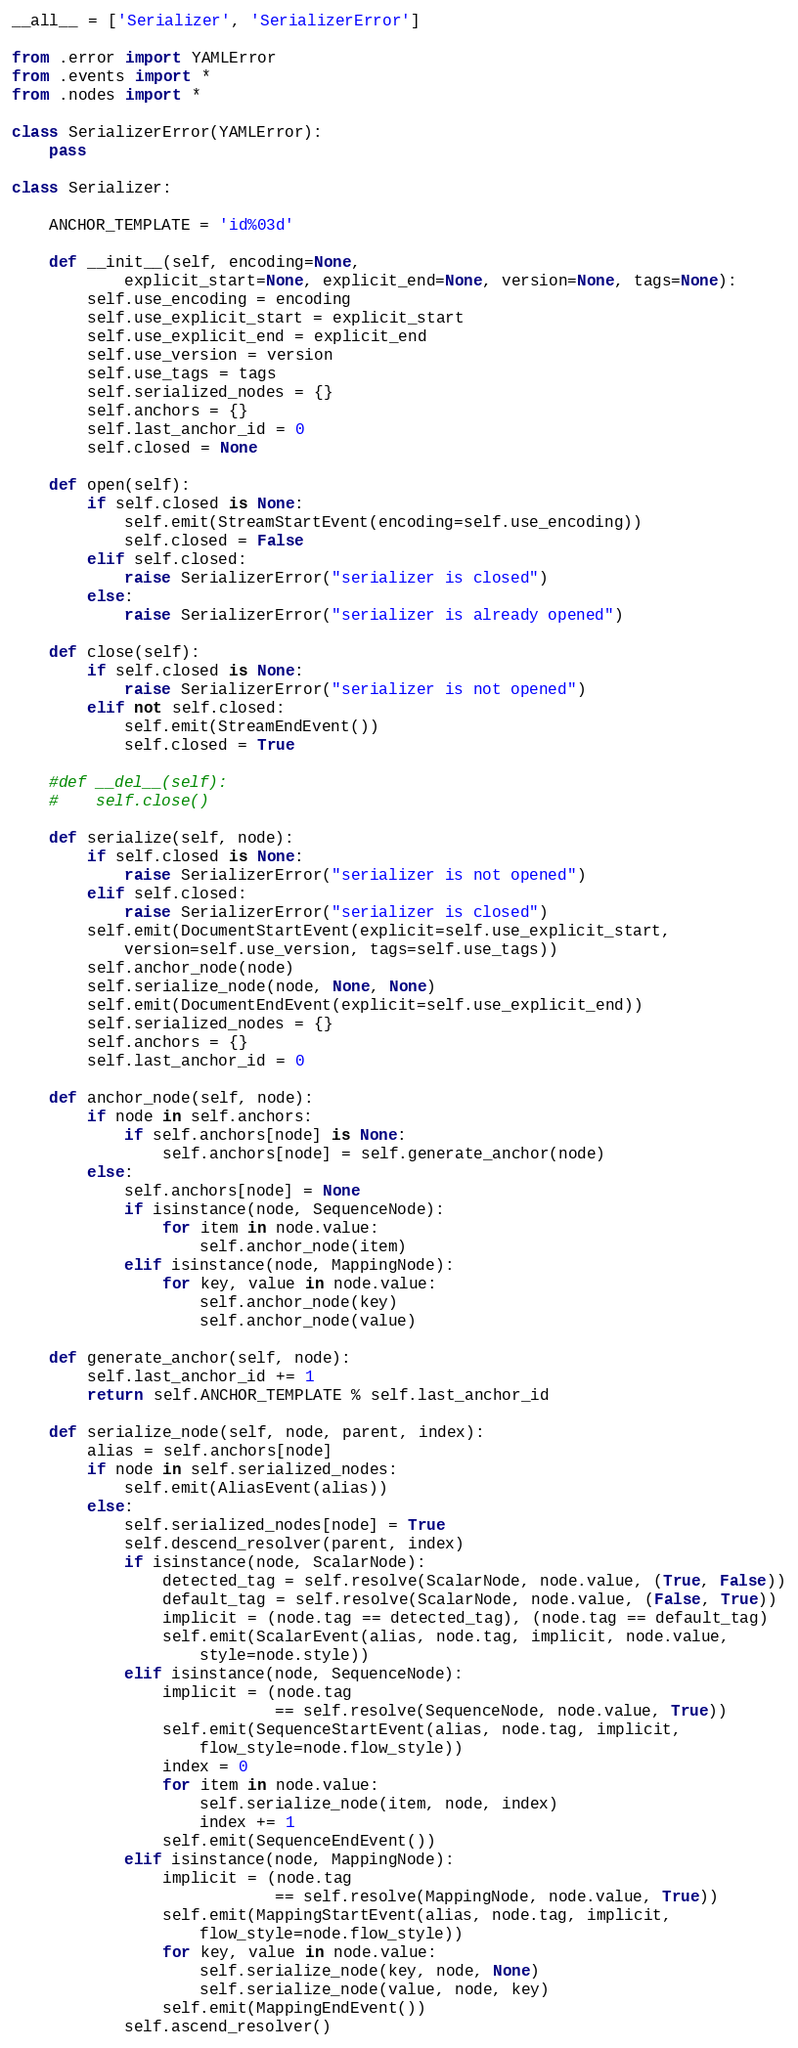<code> <loc_0><loc_0><loc_500><loc_500><_Python_>
__all__ = ['Serializer', 'SerializerError']

from .error import YAMLError
from .events import *
from .nodes import *

class SerializerError(YAMLError):
    pass

class Serializer:

    ANCHOR_TEMPLATE = 'id%03d'

    def __init__(self, encoding=None,
            explicit_start=None, explicit_end=None, version=None, tags=None):
        self.use_encoding = encoding
        self.use_explicit_start = explicit_start
        self.use_explicit_end = explicit_end
        self.use_version = version
        self.use_tags = tags
        self.serialized_nodes = {}
        self.anchors = {}
        self.last_anchor_id = 0
        self.closed = None

    def open(self):
        if self.closed is None:
            self.emit(StreamStartEvent(encoding=self.use_encoding))
            self.closed = False
        elif self.closed:
            raise SerializerError("serializer is closed")
        else:
            raise SerializerError("serializer is already opened")

    def close(self):
        if self.closed is None:
            raise SerializerError("serializer is not opened")
        elif not self.closed:
            self.emit(StreamEndEvent())
            self.closed = True

    #def __del__(self):
    #    self.close()

    def serialize(self, node):
        if self.closed is None:
            raise SerializerError("serializer is not opened")
        elif self.closed:
            raise SerializerError("serializer is closed")
        self.emit(DocumentStartEvent(explicit=self.use_explicit_start,
            version=self.use_version, tags=self.use_tags))
        self.anchor_node(node)
        self.serialize_node(node, None, None)
        self.emit(DocumentEndEvent(explicit=self.use_explicit_end))
        self.serialized_nodes = {}
        self.anchors = {}
        self.last_anchor_id = 0

    def anchor_node(self, node):
        if node in self.anchors:
            if self.anchors[node] is None:
                self.anchors[node] = self.generate_anchor(node)
        else:
            self.anchors[node] = None
            if isinstance(node, SequenceNode):
                for item in node.value:
                    self.anchor_node(item)
            elif isinstance(node, MappingNode):
                for key, value in node.value:
                    self.anchor_node(key)
                    self.anchor_node(value)

    def generate_anchor(self, node):
        self.last_anchor_id += 1
        return self.ANCHOR_TEMPLATE % self.last_anchor_id

    def serialize_node(self, node, parent, index):
        alias = self.anchors[node]
        if node in self.serialized_nodes:
            self.emit(AliasEvent(alias))
        else:
            self.serialized_nodes[node] = True
            self.descend_resolver(parent, index)
            if isinstance(node, ScalarNode):
                detected_tag = self.resolve(ScalarNode, node.value, (True, False))
                default_tag = self.resolve(ScalarNode, node.value, (False, True))
                implicit = (node.tag == detected_tag), (node.tag == default_tag)
                self.emit(ScalarEvent(alias, node.tag, implicit, node.value,
                    style=node.style))
            elif isinstance(node, SequenceNode):
                implicit = (node.tag
                            == self.resolve(SequenceNode, node.value, True))
                self.emit(SequenceStartEvent(alias, node.tag, implicit,
                    flow_style=node.flow_style))
                index = 0
                for item in node.value:
                    self.serialize_node(item, node, index)
                    index += 1
                self.emit(SequenceEndEvent())
            elif isinstance(node, MappingNode):
                implicit = (node.tag
                            == self.resolve(MappingNode, node.value, True))
                self.emit(MappingStartEvent(alias, node.tag, implicit,
                    flow_style=node.flow_style))
                for key, value in node.value:
                    self.serialize_node(key, node, None)
                    self.serialize_node(value, node, key)
                self.emit(MappingEndEvent())
            self.ascend_resolver()

</code> 